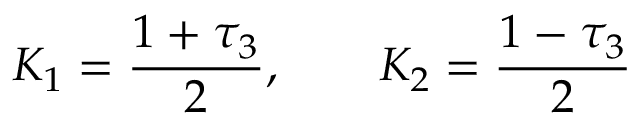<formula> <loc_0><loc_0><loc_500><loc_500>K _ { 1 } = \frac { 1 + \tau _ { 3 } } { 2 } , K _ { 2 } = \frac { 1 - \tau _ { 3 } } { 2 }</formula> 